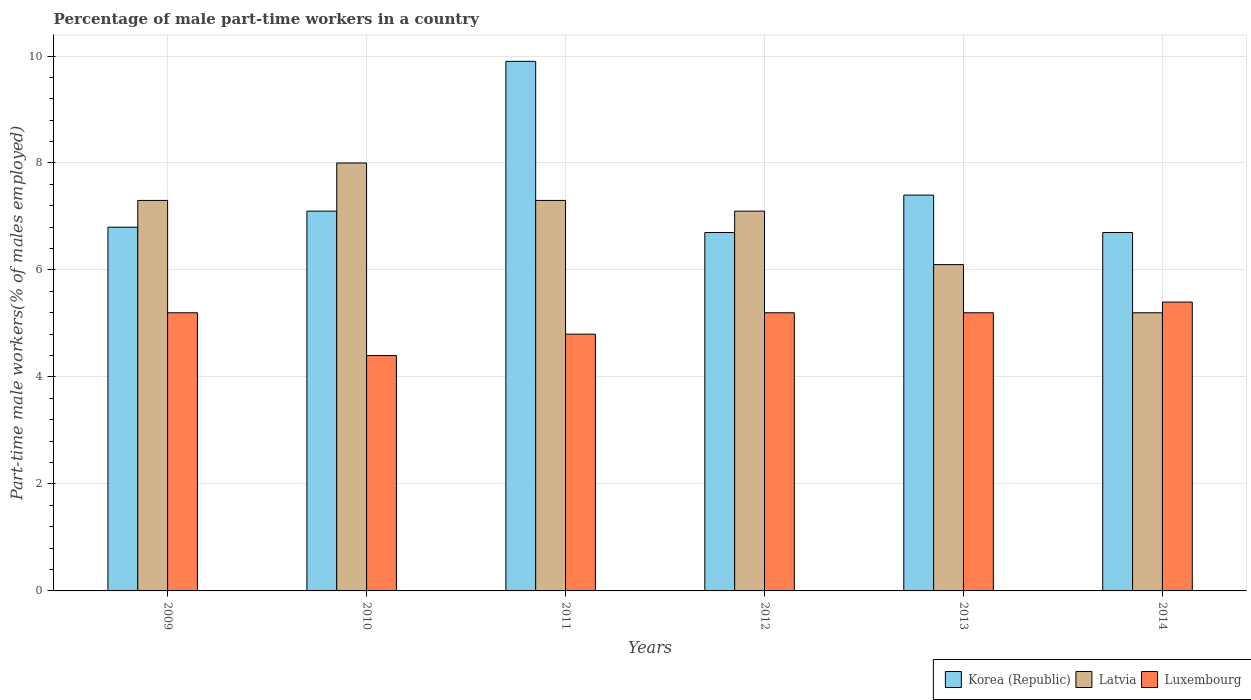How many different coloured bars are there?
Make the answer very short. 3. How many groups of bars are there?
Offer a very short reply. 6. How many bars are there on the 5th tick from the left?
Your answer should be very brief. 3. How many bars are there on the 4th tick from the right?
Ensure brevity in your answer.  3. What is the label of the 5th group of bars from the left?
Offer a very short reply. 2013. What is the percentage of male part-time workers in Luxembourg in 2009?
Provide a succinct answer. 5.2. Across all years, what is the maximum percentage of male part-time workers in Luxembourg?
Provide a succinct answer. 5.4. Across all years, what is the minimum percentage of male part-time workers in Luxembourg?
Make the answer very short. 4.4. In which year was the percentage of male part-time workers in Korea (Republic) minimum?
Your answer should be compact. 2012. What is the total percentage of male part-time workers in Luxembourg in the graph?
Your answer should be compact. 30.2. What is the difference between the percentage of male part-time workers in Luxembourg in 2011 and that in 2012?
Offer a terse response. -0.4. What is the difference between the percentage of male part-time workers in Latvia in 2010 and the percentage of male part-time workers in Luxembourg in 2009?
Keep it short and to the point. 2.8. What is the average percentage of male part-time workers in Korea (Republic) per year?
Make the answer very short. 7.43. In the year 2014, what is the difference between the percentage of male part-time workers in Latvia and percentage of male part-time workers in Luxembourg?
Offer a terse response. -0.2. What is the ratio of the percentage of male part-time workers in Korea (Republic) in 2010 to that in 2014?
Make the answer very short. 1.06. What is the difference between the highest and the second highest percentage of male part-time workers in Latvia?
Make the answer very short. 0.7. What is the difference between the highest and the lowest percentage of male part-time workers in Luxembourg?
Keep it short and to the point. 1. Is the sum of the percentage of male part-time workers in Luxembourg in 2009 and 2012 greater than the maximum percentage of male part-time workers in Latvia across all years?
Give a very brief answer. Yes. What does the 3rd bar from the left in 2012 represents?
Provide a succinct answer. Luxembourg. How many bars are there?
Keep it short and to the point. 18. How many years are there in the graph?
Ensure brevity in your answer.  6. Are the values on the major ticks of Y-axis written in scientific E-notation?
Your response must be concise. No. Does the graph contain any zero values?
Give a very brief answer. No. Where does the legend appear in the graph?
Your response must be concise. Bottom right. How are the legend labels stacked?
Give a very brief answer. Horizontal. What is the title of the graph?
Provide a succinct answer. Percentage of male part-time workers in a country. Does "Belgium" appear as one of the legend labels in the graph?
Your answer should be compact. No. What is the label or title of the X-axis?
Your answer should be very brief. Years. What is the label or title of the Y-axis?
Offer a terse response. Part-time male workers(% of males employed). What is the Part-time male workers(% of males employed) in Korea (Republic) in 2009?
Offer a very short reply. 6.8. What is the Part-time male workers(% of males employed) of Latvia in 2009?
Make the answer very short. 7.3. What is the Part-time male workers(% of males employed) in Luxembourg in 2009?
Provide a short and direct response. 5.2. What is the Part-time male workers(% of males employed) of Korea (Republic) in 2010?
Give a very brief answer. 7.1. What is the Part-time male workers(% of males employed) in Latvia in 2010?
Make the answer very short. 8. What is the Part-time male workers(% of males employed) of Luxembourg in 2010?
Offer a terse response. 4.4. What is the Part-time male workers(% of males employed) in Korea (Republic) in 2011?
Make the answer very short. 9.9. What is the Part-time male workers(% of males employed) in Latvia in 2011?
Give a very brief answer. 7.3. What is the Part-time male workers(% of males employed) in Luxembourg in 2011?
Your answer should be very brief. 4.8. What is the Part-time male workers(% of males employed) in Korea (Republic) in 2012?
Offer a very short reply. 6.7. What is the Part-time male workers(% of males employed) of Latvia in 2012?
Your answer should be compact. 7.1. What is the Part-time male workers(% of males employed) of Luxembourg in 2012?
Offer a very short reply. 5.2. What is the Part-time male workers(% of males employed) in Korea (Republic) in 2013?
Offer a very short reply. 7.4. What is the Part-time male workers(% of males employed) in Latvia in 2013?
Your response must be concise. 6.1. What is the Part-time male workers(% of males employed) of Luxembourg in 2013?
Your answer should be compact. 5.2. What is the Part-time male workers(% of males employed) in Korea (Republic) in 2014?
Provide a short and direct response. 6.7. What is the Part-time male workers(% of males employed) of Latvia in 2014?
Make the answer very short. 5.2. What is the Part-time male workers(% of males employed) in Luxembourg in 2014?
Make the answer very short. 5.4. Across all years, what is the maximum Part-time male workers(% of males employed) in Korea (Republic)?
Your answer should be compact. 9.9. Across all years, what is the maximum Part-time male workers(% of males employed) in Luxembourg?
Offer a very short reply. 5.4. Across all years, what is the minimum Part-time male workers(% of males employed) in Korea (Republic)?
Ensure brevity in your answer.  6.7. Across all years, what is the minimum Part-time male workers(% of males employed) in Latvia?
Ensure brevity in your answer.  5.2. Across all years, what is the minimum Part-time male workers(% of males employed) in Luxembourg?
Provide a short and direct response. 4.4. What is the total Part-time male workers(% of males employed) of Korea (Republic) in the graph?
Provide a succinct answer. 44.6. What is the total Part-time male workers(% of males employed) in Luxembourg in the graph?
Provide a succinct answer. 30.2. What is the difference between the Part-time male workers(% of males employed) of Luxembourg in 2009 and that in 2010?
Offer a terse response. 0.8. What is the difference between the Part-time male workers(% of males employed) of Korea (Republic) in 2009 and that in 2011?
Give a very brief answer. -3.1. What is the difference between the Part-time male workers(% of males employed) of Latvia in 2009 and that in 2011?
Your answer should be very brief. 0. What is the difference between the Part-time male workers(% of males employed) in Luxembourg in 2009 and that in 2011?
Provide a succinct answer. 0.4. What is the difference between the Part-time male workers(% of males employed) of Latvia in 2009 and that in 2012?
Your response must be concise. 0.2. What is the difference between the Part-time male workers(% of males employed) of Luxembourg in 2009 and that in 2012?
Provide a succinct answer. 0. What is the difference between the Part-time male workers(% of males employed) of Latvia in 2009 and that in 2014?
Keep it short and to the point. 2.1. What is the difference between the Part-time male workers(% of males employed) in Luxembourg in 2009 and that in 2014?
Provide a succinct answer. -0.2. What is the difference between the Part-time male workers(% of males employed) of Latvia in 2010 and that in 2011?
Offer a very short reply. 0.7. What is the difference between the Part-time male workers(% of males employed) of Korea (Republic) in 2010 and that in 2012?
Your answer should be very brief. 0.4. What is the difference between the Part-time male workers(% of males employed) in Latvia in 2010 and that in 2012?
Your response must be concise. 0.9. What is the difference between the Part-time male workers(% of males employed) in Luxembourg in 2010 and that in 2012?
Make the answer very short. -0.8. What is the difference between the Part-time male workers(% of males employed) in Korea (Republic) in 2010 and that in 2014?
Provide a short and direct response. 0.4. What is the difference between the Part-time male workers(% of males employed) in Korea (Republic) in 2011 and that in 2012?
Your answer should be compact. 3.2. What is the difference between the Part-time male workers(% of males employed) of Korea (Republic) in 2011 and that in 2013?
Give a very brief answer. 2.5. What is the difference between the Part-time male workers(% of males employed) of Latvia in 2011 and that in 2013?
Keep it short and to the point. 1.2. What is the difference between the Part-time male workers(% of males employed) in Latvia in 2011 and that in 2014?
Provide a succinct answer. 2.1. What is the difference between the Part-time male workers(% of males employed) of Luxembourg in 2011 and that in 2014?
Provide a short and direct response. -0.6. What is the difference between the Part-time male workers(% of males employed) in Korea (Republic) in 2012 and that in 2013?
Your response must be concise. -0.7. What is the difference between the Part-time male workers(% of males employed) of Latvia in 2012 and that in 2013?
Offer a terse response. 1. What is the difference between the Part-time male workers(% of males employed) of Luxembourg in 2012 and that in 2013?
Provide a short and direct response. 0. What is the difference between the Part-time male workers(% of males employed) in Latvia in 2012 and that in 2014?
Your answer should be compact. 1.9. What is the difference between the Part-time male workers(% of males employed) in Luxembourg in 2012 and that in 2014?
Make the answer very short. -0.2. What is the difference between the Part-time male workers(% of males employed) of Korea (Republic) in 2013 and that in 2014?
Ensure brevity in your answer.  0.7. What is the difference between the Part-time male workers(% of males employed) in Latvia in 2013 and that in 2014?
Provide a succinct answer. 0.9. What is the difference between the Part-time male workers(% of males employed) of Korea (Republic) in 2009 and the Part-time male workers(% of males employed) of Latvia in 2010?
Your response must be concise. -1.2. What is the difference between the Part-time male workers(% of males employed) of Korea (Republic) in 2009 and the Part-time male workers(% of males employed) of Luxembourg in 2010?
Your answer should be very brief. 2.4. What is the difference between the Part-time male workers(% of males employed) in Korea (Republic) in 2009 and the Part-time male workers(% of males employed) in Latvia in 2011?
Ensure brevity in your answer.  -0.5. What is the difference between the Part-time male workers(% of males employed) of Korea (Republic) in 2009 and the Part-time male workers(% of males employed) of Luxembourg in 2011?
Your answer should be compact. 2. What is the difference between the Part-time male workers(% of males employed) in Korea (Republic) in 2009 and the Part-time male workers(% of males employed) in Latvia in 2012?
Provide a short and direct response. -0.3. What is the difference between the Part-time male workers(% of males employed) in Latvia in 2009 and the Part-time male workers(% of males employed) in Luxembourg in 2012?
Your answer should be compact. 2.1. What is the difference between the Part-time male workers(% of males employed) in Latvia in 2009 and the Part-time male workers(% of males employed) in Luxembourg in 2013?
Provide a succinct answer. 2.1. What is the difference between the Part-time male workers(% of males employed) in Korea (Republic) in 2009 and the Part-time male workers(% of males employed) in Latvia in 2014?
Your response must be concise. 1.6. What is the difference between the Part-time male workers(% of males employed) in Korea (Republic) in 2009 and the Part-time male workers(% of males employed) in Luxembourg in 2014?
Keep it short and to the point. 1.4. What is the difference between the Part-time male workers(% of males employed) in Latvia in 2010 and the Part-time male workers(% of males employed) in Luxembourg in 2011?
Your answer should be very brief. 3.2. What is the difference between the Part-time male workers(% of males employed) of Latvia in 2010 and the Part-time male workers(% of males employed) of Luxembourg in 2012?
Your answer should be compact. 2.8. What is the difference between the Part-time male workers(% of males employed) in Korea (Republic) in 2010 and the Part-time male workers(% of males employed) in Latvia in 2013?
Provide a short and direct response. 1. What is the difference between the Part-time male workers(% of males employed) in Korea (Republic) in 2010 and the Part-time male workers(% of males employed) in Luxembourg in 2013?
Give a very brief answer. 1.9. What is the difference between the Part-time male workers(% of males employed) in Korea (Republic) in 2010 and the Part-time male workers(% of males employed) in Latvia in 2014?
Your answer should be very brief. 1.9. What is the difference between the Part-time male workers(% of males employed) in Korea (Republic) in 2010 and the Part-time male workers(% of males employed) in Luxembourg in 2014?
Keep it short and to the point. 1.7. What is the difference between the Part-time male workers(% of males employed) in Korea (Republic) in 2011 and the Part-time male workers(% of males employed) in Luxembourg in 2013?
Your answer should be compact. 4.7. What is the difference between the Part-time male workers(% of males employed) of Latvia in 2011 and the Part-time male workers(% of males employed) of Luxembourg in 2013?
Offer a terse response. 2.1. What is the difference between the Part-time male workers(% of males employed) of Korea (Republic) in 2012 and the Part-time male workers(% of males employed) of Latvia in 2013?
Provide a short and direct response. 0.6. What is the difference between the Part-time male workers(% of males employed) of Korea (Republic) in 2012 and the Part-time male workers(% of males employed) of Luxembourg in 2013?
Your answer should be compact. 1.5. What is the difference between the Part-time male workers(% of males employed) of Latvia in 2012 and the Part-time male workers(% of males employed) of Luxembourg in 2013?
Your answer should be compact. 1.9. What is the difference between the Part-time male workers(% of males employed) in Korea (Republic) in 2012 and the Part-time male workers(% of males employed) in Latvia in 2014?
Your response must be concise. 1.5. What is the difference between the Part-time male workers(% of males employed) of Latvia in 2012 and the Part-time male workers(% of males employed) of Luxembourg in 2014?
Offer a very short reply. 1.7. What is the difference between the Part-time male workers(% of males employed) of Korea (Republic) in 2013 and the Part-time male workers(% of males employed) of Latvia in 2014?
Your response must be concise. 2.2. What is the difference between the Part-time male workers(% of males employed) of Latvia in 2013 and the Part-time male workers(% of males employed) of Luxembourg in 2014?
Offer a very short reply. 0.7. What is the average Part-time male workers(% of males employed) of Korea (Republic) per year?
Your answer should be very brief. 7.43. What is the average Part-time male workers(% of males employed) in Latvia per year?
Provide a short and direct response. 6.83. What is the average Part-time male workers(% of males employed) of Luxembourg per year?
Give a very brief answer. 5.03. In the year 2009, what is the difference between the Part-time male workers(% of males employed) in Korea (Republic) and Part-time male workers(% of males employed) in Luxembourg?
Your response must be concise. 1.6. In the year 2009, what is the difference between the Part-time male workers(% of males employed) in Latvia and Part-time male workers(% of males employed) in Luxembourg?
Offer a very short reply. 2.1. In the year 2010, what is the difference between the Part-time male workers(% of males employed) in Korea (Republic) and Part-time male workers(% of males employed) in Luxembourg?
Give a very brief answer. 2.7. In the year 2011, what is the difference between the Part-time male workers(% of males employed) of Korea (Republic) and Part-time male workers(% of males employed) of Latvia?
Provide a short and direct response. 2.6. In the year 2011, what is the difference between the Part-time male workers(% of males employed) of Latvia and Part-time male workers(% of males employed) of Luxembourg?
Your response must be concise. 2.5. In the year 2012, what is the difference between the Part-time male workers(% of males employed) of Latvia and Part-time male workers(% of males employed) of Luxembourg?
Give a very brief answer. 1.9. In the year 2013, what is the difference between the Part-time male workers(% of males employed) in Korea (Republic) and Part-time male workers(% of males employed) in Luxembourg?
Ensure brevity in your answer.  2.2. In the year 2014, what is the difference between the Part-time male workers(% of males employed) of Korea (Republic) and Part-time male workers(% of males employed) of Luxembourg?
Give a very brief answer. 1.3. What is the ratio of the Part-time male workers(% of males employed) of Korea (Republic) in 2009 to that in 2010?
Your answer should be very brief. 0.96. What is the ratio of the Part-time male workers(% of males employed) of Latvia in 2009 to that in 2010?
Ensure brevity in your answer.  0.91. What is the ratio of the Part-time male workers(% of males employed) in Luxembourg in 2009 to that in 2010?
Ensure brevity in your answer.  1.18. What is the ratio of the Part-time male workers(% of males employed) in Korea (Republic) in 2009 to that in 2011?
Offer a terse response. 0.69. What is the ratio of the Part-time male workers(% of males employed) of Korea (Republic) in 2009 to that in 2012?
Your response must be concise. 1.01. What is the ratio of the Part-time male workers(% of males employed) of Latvia in 2009 to that in 2012?
Your response must be concise. 1.03. What is the ratio of the Part-time male workers(% of males employed) of Luxembourg in 2009 to that in 2012?
Give a very brief answer. 1. What is the ratio of the Part-time male workers(% of males employed) of Korea (Republic) in 2009 to that in 2013?
Your answer should be very brief. 0.92. What is the ratio of the Part-time male workers(% of males employed) of Latvia in 2009 to that in 2013?
Provide a short and direct response. 1.2. What is the ratio of the Part-time male workers(% of males employed) of Korea (Republic) in 2009 to that in 2014?
Your response must be concise. 1.01. What is the ratio of the Part-time male workers(% of males employed) of Latvia in 2009 to that in 2014?
Provide a succinct answer. 1.4. What is the ratio of the Part-time male workers(% of males employed) in Korea (Republic) in 2010 to that in 2011?
Offer a very short reply. 0.72. What is the ratio of the Part-time male workers(% of males employed) of Latvia in 2010 to that in 2011?
Your answer should be compact. 1.1. What is the ratio of the Part-time male workers(% of males employed) in Korea (Republic) in 2010 to that in 2012?
Offer a very short reply. 1.06. What is the ratio of the Part-time male workers(% of males employed) in Latvia in 2010 to that in 2012?
Offer a terse response. 1.13. What is the ratio of the Part-time male workers(% of males employed) of Luxembourg in 2010 to that in 2012?
Ensure brevity in your answer.  0.85. What is the ratio of the Part-time male workers(% of males employed) in Korea (Republic) in 2010 to that in 2013?
Provide a short and direct response. 0.96. What is the ratio of the Part-time male workers(% of males employed) in Latvia in 2010 to that in 2013?
Your response must be concise. 1.31. What is the ratio of the Part-time male workers(% of males employed) of Luxembourg in 2010 to that in 2013?
Provide a short and direct response. 0.85. What is the ratio of the Part-time male workers(% of males employed) of Korea (Republic) in 2010 to that in 2014?
Ensure brevity in your answer.  1.06. What is the ratio of the Part-time male workers(% of males employed) in Latvia in 2010 to that in 2014?
Offer a terse response. 1.54. What is the ratio of the Part-time male workers(% of males employed) in Luxembourg in 2010 to that in 2014?
Offer a very short reply. 0.81. What is the ratio of the Part-time male workers(% of males employed) of Korea (Republic) in 2011 to that in 2012?
Your answer should be very brief. 1.48. What is the ratio of the Part-time male workers(% of males employed) of Latvia in 2011 to that in 2012?
Provide a succinct answer. 1.03. What is the ratio of the Part-time male workers(% of males employed) of Korea (Republic) in 2011 to that in 2013?
Your answer should be compact. 1.34. What is the ratio of the Part-time male workers(% of males employed) of Latvia in 2011 to that in 2013?
Provide a succinct answer. 1.2. What is the ratio of the Part-time male workers(% of males employed) in Korea (Republic) in 2011 to that in 2014?
Your answer should be compact. 1.48. What is the ratio of the Part-time male workers(% of males employed) in Latvia in 2011 to that in 2014?
Provide a succinct answer. 1.4. What is the ratio of the Part-time male workers(% of males employed) of Korea (Republic) in 2012 to that in 2013?
Offer a very short reply. 0.91. What is the ratio of the Part-time male workers(% of males employed) in Latvia in 2012 to that in 2013?
Keep it short and to the point. 1.16. What is the ratio of the Part-time male workers(% of males employed) of Korea (Republic) in 2012 to that in 2014?
Your answer should be compact. 1. What is the ratio of the Part-time male workers(% of males employed) in Latvia in 2012 to that in 2014?
Offer a very short reply. 1.37. What is the ratio of the Part-time male workers(% of males employed) of Luxembourg in 2012 to that in 2014?
Offer a very short reply. 0.96. What is the ratio of the Part-time male workers(% of males employed) in Korea (Republic) in 2013 to that in 2014?
Offer a very short reply. 1.1. What is the ratio of the Part-time male workers(% of males employed) in Latvia in 2013 to that in 2014?
Your answer should be compact. 1.17. What is the difference between the highest and the second highest Part-time male workers(% of males employed) in Luxembourg?
Your response must be concise. 0.2. What is the difference between the highest and the lowest Part-time male workers(% of males employed) of Latvia?
Offer a terse response. 2.8. What is the difference between the highest and the lowest Part-time male workers(% of males employed) of Luxembourg?
Keep it short and to the point. 1. 